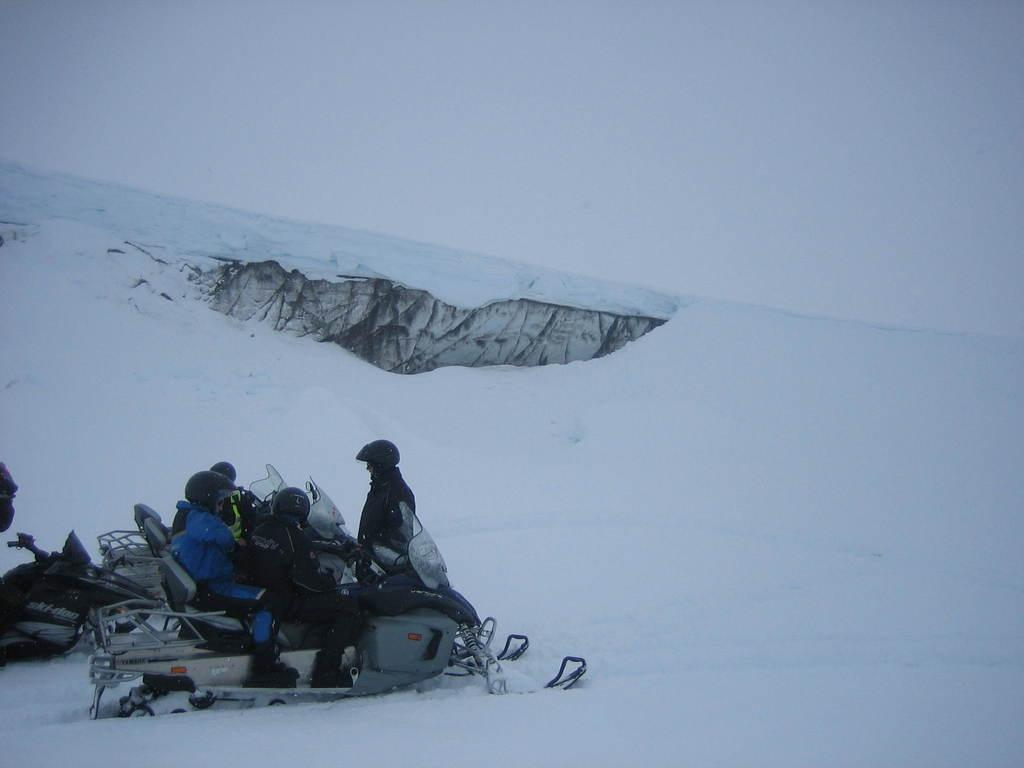What are the persons in the image doing? The persons in the image are sitting on a vehicle. What is the surface the vehicle is on? The vehicle is on ice. Are there any other people in the image besides the ones sitting on the vehicle? Yes, there is a person standing in the image. What type of tail can be seen on the person standing in the image? There is no tail visible on the person standing in the image. What emotion is the person standing in the image experiencing? The image does not provide enough information to determine the emotion of the person standing in the image. 